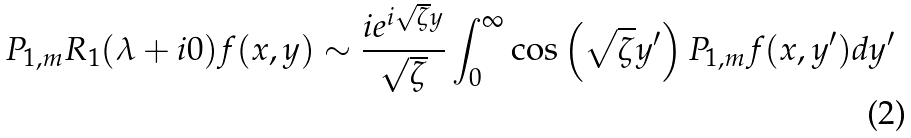<formula> <loc_0><loc_0><loc_500><loc_500>P _ { 1 , m } R _ { 1 } ( \lambda + i 0 ) f ( x , y ) \sim \frac { i e ^ { i \sqrt { \zeta } y } } { \sqrt { \zeta } } \int _ { 0 } ^ { \infty } \cos \left ( \sqrt { \zeta } y ^ { \prime } \right ) P _ { 1 , m } f ( x , y ^ { \prime } ) d y ^ { \prime }</formula> 